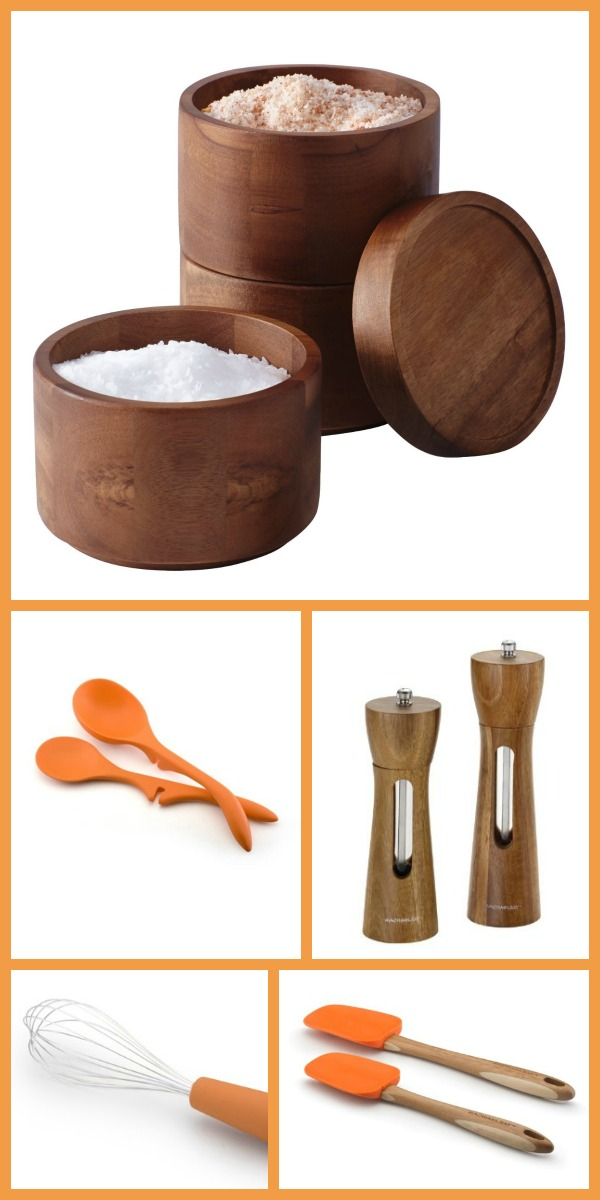Describe a scenario where the wooden salt and pepper grinders become the stars of a family dinner. During a cozy family dinner, the wooden salt and pepper grinders take center stage. As the family gathers around the table, the grinders are passed hand to hand, each person eagerly seasoning their food to perfection. Their polished wooden finish complements the natural and rustic table setting. With every twist and turn, the grinders release the fresh, aromatic spices, enhancing the flavors of the homemade dishes. The family enjoys stories and laughter, with the grinders symbolizing the warmth and unity around the dinner table. 